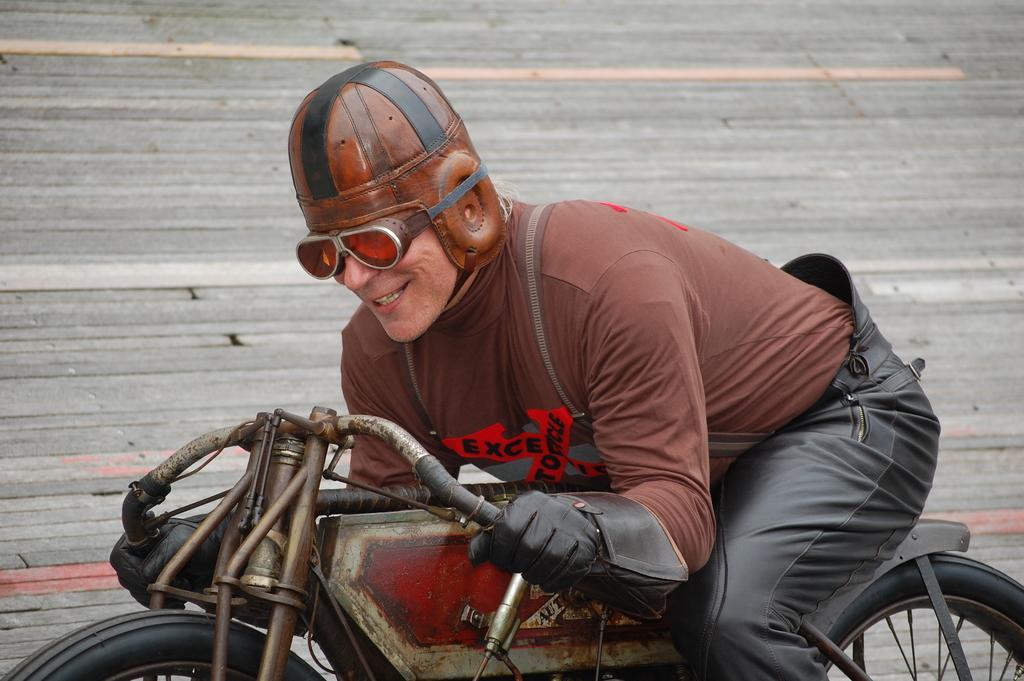Can you describe this image briefly? Man riding bicycle. 